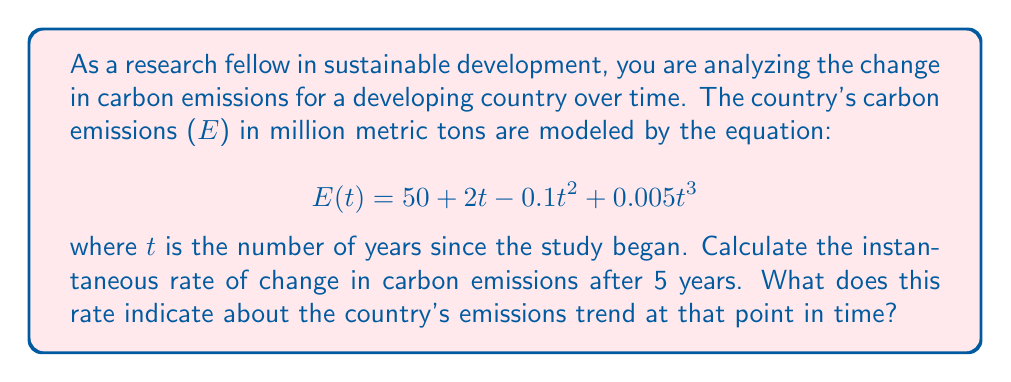What is the answer to this math problem? To solve this problem, we need to find the derivative of the carbon emissions function and evaluate it at t = 5. This will give us the instantaneous rate of change.

1. First, let's find the derivative of E(t):
   $$E'(t) = \frac{d}{dt}(50 + 2t - 0.1t^2 + 0.005t^3)$$
   $$E'(t) = 0 + 2 - 0.2t + 0.015t^2$$

2. Now, we evaluate E'(t) at t = 5:
   $$E'(5) = 2 - 0.2(5) + 0.015(5^2)$$
   $$E'(5) = 2 - 1 + 0.015(25)$$
   $$E'(5) = 1 + 0.375$$
   $$E'(5) = 1.375$$

3. Interpreting the result:
   The rate of change is positive, indicating that carbon emissions are still increasing after 5 years. However, the rate is relatively low (1.375 million metric tons per year), which suggests that the growth in emissions is slowing down. This could be due to the implementation of sustainable practices or the transition to cleaner energy sources.

   To further understand the emissions trend, we could calculate the second derivative to determine if the rate of change is increasing or decreasing at this point.
Answer: The instantaneous rate of change in carbon emissions after 5 years is 1.375 million metric tons per year. This positive value indicates that emissions are still increasing, but the relatively low rate suggests a potential slowing of emission growth. 